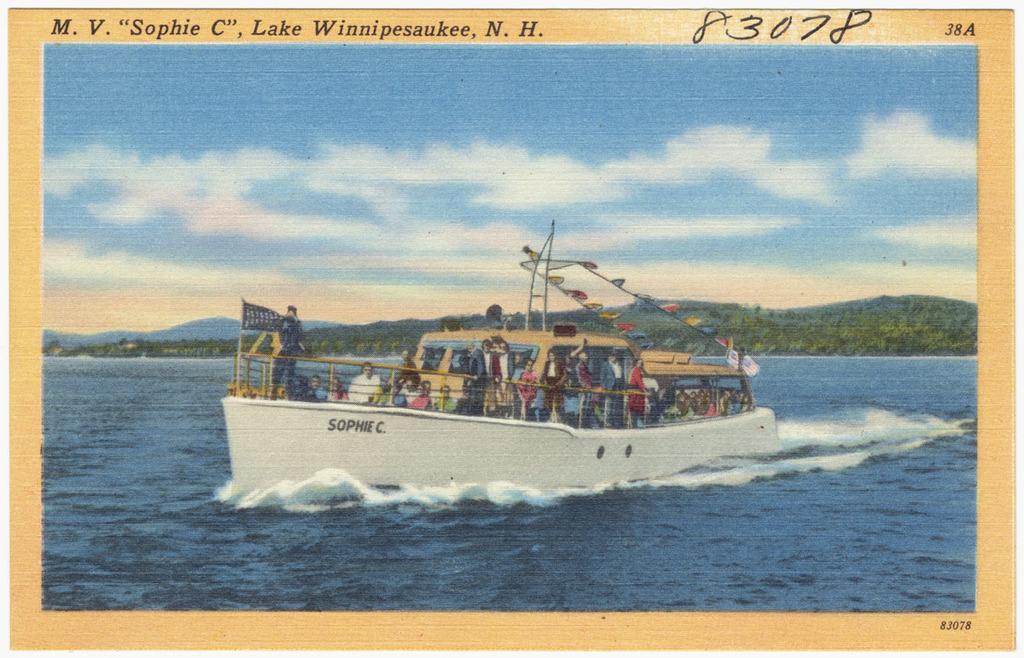What lake is this a picture of?
Offer a very short reply. Winnipesaukee. 